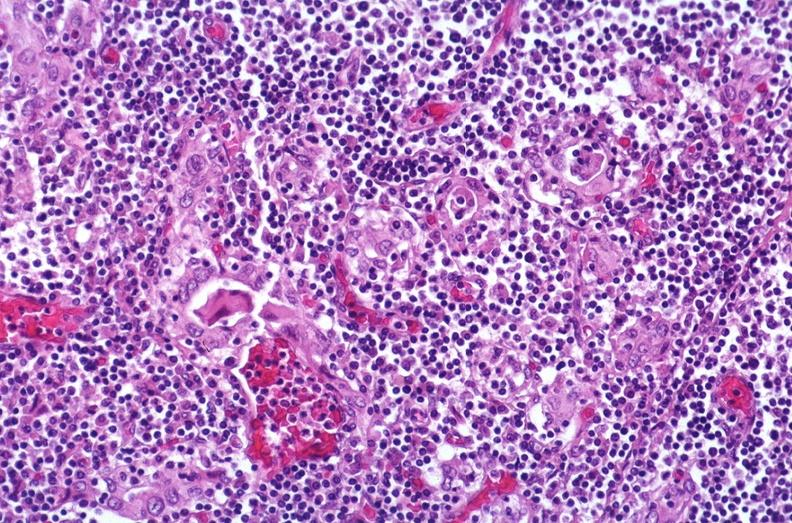does this image show hashimoto 's thyroiditis?
Answer the question using a single word or phrase. Yes 